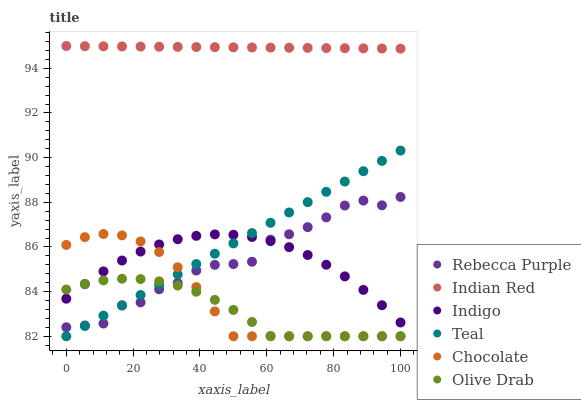Does Olive Drab have the minimum area under the curve?
Answer yes or no. Yes. Does Indian Red have the maximum area under the curve?
Answer yes or no. Yes. Does Chocolate have the minimum area under the curve?
Answer yes or no. No. Does Chocolate have the maximum area under the curve?
Answer yes or no. No. Is Indian Red the smoothest?
Answer yes or no. Yes. Is Rebecca Purple the roughest?
Answer yes or no. Yes. Is Chocolate the smoothest?
Answer yes or no. No. Is Chocolate the roughest?
Answer yes or no. No. Does Chocolate have the lowest value?
Answer yes or no. Yes. Does Indian Red have the lowest value?
Answer yes or no. No. Does Indian Red have the highest value?
Answer yes or no. Yes. Does Chocolate have the highest value?
Answer yes or no. No. Is Olive Drab less than Indian Red?
Answer yes or no. Yes. Is Indian Red greater than Teal?
Answer yes or no. Yes. Does Olive Drab intersect Indigo?
Answer yes or no. Yes. Is Olive Drab less than Indigo?
Answer yes or no. No. Is Olive Drab greater than Indigo?
Answer yes or no. No. Does Olive Drab intersect Indian Red?
Answer yes or no. No. 